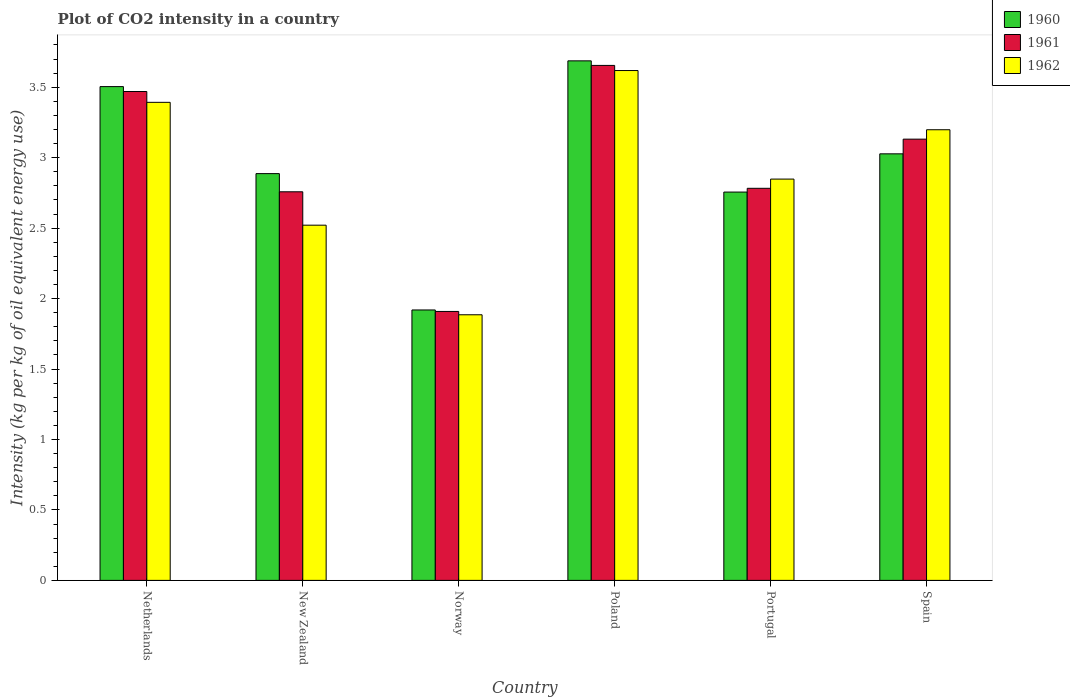How many different coloured bars are there?
Offer a terse response. 3. How many bars are there on the 4th tick from the left?
Give a very brief answer. 3. How many bars are there on the 4th tick from the right?
Your answer should be very brief. 3. In how many cases, is the number of bars for a given country not equal to the number of legend labels?
Your response must be concise. 0. What is the CO2 intensity in in 1961 in Poland?
Ensure brevity in your answer.  3.66. Across all countries, what is the maximum CO2 intensity in in 1961?
Your response must be concise. 3.66. Across all countries, what is the minimum CO2 intensity in in 1962?
Provide a short and direct response. 1.89. In which country was the CO2 intensity in in 1960 maximum?
Keep it short and to the point. Poland. In which country was the CO2 intensity in in 1961 minimum?
Provide a succinct answer. Norway. What is the total CO2 intensity in in 1962 in the graph?
Offer a very short reply. 17.46. What is the difference between the CO2 intensity in in 1962 in Poland and that in Spain?
Your answer should be very brief. 0.42. What is the difference between the CO2 intensity in in 1961 in Spain and the CO2 intensity in in 1962 in Netherlands?
Provide a short and direct response. -0.26. What is the average CO2 intensity in in 1962 per country?
Make the answer very short. 2.91. What is the difference between the CO2 intensity in of/in 1960 and CO2 intensity in of/in 1961 in Poland?
Provide a succinct answer. 0.03. In how many countries, is the CO2 intensity in in 1960 greater than 2.4 kg?
Offer a terse response. 5. What is the ratio of the CO2 intensity in in 1962 in Netherlands to that in Poland?
Give a very brief answer. 0.94. Is the CO2 intensity in in 1962 in Poland less than that in Portugal?
Your answer should be compact. No. Is the difference between the CO2 intensity in in 1960 in Netherlands and Spain greater than the difference between the CO2 intensity in in 1961 in Netherlands and Spain?
Your answer should be very brief. Yes. What is the difference between the highest and the second highest CO2 intensity in in 1960?
Make the answer very short. -0.18. What is the difference between the highest and the lowest CO2 intensity in in 1961?
Your answer should be compact. 1.75. In how many countries, is the CO2 intensity in in 1962 greater than the average CO2 intensity in in 1962 taken over all countries?
Your answer should be very brief. 3. Is the sum of the CO2 intensity in in 1960 in Poland and Spain greater than the maximum CO2 intensity in in 1962 across all countries?
Offer a terse response. Yes. What does the 1st bar from the left in Norway represents?
Keep it short and to the point. 1960. What does the 2nd bar from the right in Spain represents?
Offer a terse response. 1961. Is it the case that in every country, the sum of the CO2 intensity in in 1962 and CO2 intensity in in 1961 is greater than the CO2 intensity in in 1960?
Your answer should be very brief. Yes. How many countries are there in the graph?
Make the answer very short. 6. What is the difference between two consecutive major ticks on the Y-axis?
Your answer should be compact. 0.5. Are the values on the major ticks of Y-axis written in scientific E-notation?
Your response must be concise. No. Does the graph contain any zero values?
Give a very brief answer. No. Does the graph contain grids?
Your response must be concise. No. How many legend labels are there?
Offer a terse response. 3. How are the legend labels stacked?
Provide a succinct answer. Vertical. What is the title of the graph?
Your answer should be very brief. Plot of CO2 intensity in a country. Does "2008" appear as one of the legend labels in the graph?
Your response must be concise. No. What is the label or title of the X-axis?
Provide a short and direct response. Country. What is the label or title of the Y-axis?
Keep it short and to the point. Intensity (kg per kg of oil equivalent energy use). What is the Intensity (kg per kg of oil equivalent energy use) in 1960 in Netherlands?
Make the answer very short. 3.5. What is the Intensity (kg per kg of oil equivalent energy use) of 1961 in Netherlands?
Make the answer very short. 3.47. What is the Intensity (kg per kg of oil equivalent energy use) of 1962 in Netherlands?
Make the answer very short. 3.39. What is the Intensity (kg per kg of oil equivalent energy use) of 1960 in New Zealand?
Provide a succinct answer. 2.89. What is the Intensity (kg per kg of oil equivalent energy use) of 1961 in New Zealand?
Make the answer very short. 2.76. What is the Intensity (kg per kg of oil equivalent energy use) of 1962 in New Zealand?
Offer a very short reply. 2.52. What is the Intensity (kg per kg of oil equivalent energy use) in 1960 in Norway?
Ensure brevity in your answer.  1.92. What is the Intensity (kg per kg of oil equivalent energy use) of 1961 in Norway?
Give a very brief answer. 1.91. What is the Intensity (kg per kg of oil equivalent energy use) of 1962 in Norway?
Offer a terse response. 1.89. What is the Intensity (kg per kg of oil equivalent energy use) of 1960 in Poland?
Offer a very short reply. 3.69. What is the Intensity (kg per kg of oil equivalent energy use) of 1961 in Poland?
Offer a very short reply. 3.66. What is the Intensity (kg per kg of oil equivalent energy use) of 1962 in Poland?
Your response must be concise. 3.62. What is the Intensity (kg per kg of oil equivalent energy use) in 1960 in Portugal?
Ensure brevity in your answer.  2.76. What is the Intensity (kg per kg of oil equivalent energy use) of 1961 in Portugal?
Your response must be concise. 2.78. What is the Intensity (kg per kg of oil equivalent energy use) in 1962 in Portugal?
Ensure brevity in your answer.  2.85. What is the Intensity (kg per kg of oil equivalent energy use) in 1960 in Spain?
Your response must be concise. 3.03. What is the Intensity (kg per kg of oil equivalent energy use) in 1961 in Spain?
Provide a short and direct response. 3.13. What is the Intensity (kg per kg of oil equivalent energy use) in 1962 in Spain?
Your answer should be compact. 3.2. Across all countries, what is the maximum Intensity (kg per kg of oil equivalent energy use) of 1960?
Your answer should be compact. 3.69. Across all countries, what is the maximum Intensity (kg per kg of oil equivalent energy use) in 1961?
Keep it short and to the point. 3.66. Across all countries, what is the maximum Intensity (kg per kg of oil equivalent energy use) in 1962?
Your answer should be compact. 3.62. Across all countries, what is the minimum Intensity (kg per kg of oil equivalent energy use) in 1960?
Your answer should be very brief. 1.92. Across all countries, what is the minimum Intensity (kg per kg of oil equivalent energy use) of 1961?
Provide a succinct answer. 1.91. Across all countries, what is the minimum Intensity (kg per kg of oil equivalent energy use) in 1962?
Ensure brevity in your answer.  1.89. What is the total Intensity (kg per kg of oil equivalent energy use) of 1960 in the graph?
Offer a terse response. 17.78. What is the total Intensity (kg per kg of oil equivalent energy use) of 1961 in the graph?
Give a very brief answer. 17.71. What is the total Intensity (kg per kg of oil equivalent energy use) in 1962 in the graph?
Offer a very short reply. 17.46. What is the difference between the Intensity (kg per kg of oil equivalent energy use) in 1960 in Netherlands and that in New Zealand?
Offer a very short reply. 0.62. What is the difference between the Intensity (kg per kg of oil equivalent energy use) in 1961 in Netherlands and that in New Zealand?
Provide a succinct answer. 0.71. What is the difference between the Intensity (kg per kg of oil equivalent energy use) in 1962 in Netherlands and that in New Zealand?
Provide a succinct answer. 0.87. What is the difference between the Intensity (kg per kg of oil equivalent energy use) of 1960 in Netherlands and that in Norway?
Give a very brief answer. 1.59. What is the difference between the Intensity (kg per kg of oil equivalent energy use) in 1961 in Netherlands and that in Norway?
Provide a succinct answer. 1.56. What is the difference between the Intensity (kg per kg of oil equivalent energy use) in 1962 in Netherlands and that in Norway?
Your answer should be compact. 1.51. What is the difference between the Intensity (kg per kg of oil equivalent energy use) in 1960 in Netherlands and that in Poland?
Keep it short and to the point. -0.18. What is the difference between the Intensity (kg per kg of oil equivalent energy use) of 1961 in Netherlands and that in Poland?
Provide a short and direct response. -0.19. What is the difference between the Intensity (kg per kg of oil equivalent energy use) in 1962 in Netherlands and that in Poland?
Offer a very short reply. -0.23. What is the difference between the Intensity (kg per kg of oil equivalent energy use) of 1960 in Netherlands and that in Portugal?
Your answer should be very brief. 0.75. What is the difference between the Intensity (kg per kg of oil equivalent energy use) in 1961 in Netherlands and that in Portugal?
Give a very brief answer. 0.69. What is the difference between the Intensity (kg per kg of oil equivalent energy use) in 1962 in Netherlands and that in Portugal?
Your response must be concise. 0.54. What is the difference between the Intensity (kg per kg of oil equivalent energy use) in 1960 in Netherlands and that in Spain?
Offer a terse response. 0.48. What is the difference between the Intensity (kg per kg of oil equivalent energy use) in 1961 in Netherlands and that in Spain?
Provide a succinct answer. 0.34. What is the difference between the Intensity (kg per kg of oil equivalent energy use) in 1962 in Netherlands and that in Spain?
Make the answer very short. 0.19. What is the difference between the Intensity (kg per kg of oil equivalent energy use) in 1960 in New Zealand and that in Norway?
Offer a very short reply. 0.97. What is the difference between the Intensity (kg per kg of oil equivalent energy use) of 1961 in New Zealand and that in Norway?
Your answer should be very brief. 0.85. What is the difference between the Intensity (kg per kg of oil equivalent energy use) in 1962 in New Zealand and that in Norway?
Provide a short and direct response. 0.64. What is the difference between the Intensity (kg per kg of oil equivalent energy use) of 1960 in New Zealand and that in Poland?
Make the answer very short. -0.8. What is the difference between the Intensity (kg per kg of oil equivalent energy use) in 1961 in New Zealand and that in Poland?
Keep it short and to the point. -0.9. What is the difference between the Intensity (kg per kg of oil equivalent energy use) in 1962 in New Zealand and that in Poland?
Give a very brief answer. -1.1. What is the difference between the Intensity (kg per kg of oil equivalent energy use) in 1960 in New Zealand and that in Portugal?
Your answer should be very brief. 0.13. What is the difference between the Intensity (kg per kg of oil equivalent energy use) in 1961 in New Zealand and that in Portugal?
Provide a succinct answer. -0.02. What is the difference between the Intensity (kg per kg of oil equivalent energy use) of 1962 in New Zealand and that in Portugal?
Provide a succinct answer. -0.33. What is the difference between the Intensity (kg per kg of oil equivalent energy use) of 1960 in New Zealand and that in Spain?
Give a very brief answer. -0.14. What is the difference between the Intensity (kg per kg of oil equivalent energy use) of 1961 in New Zealand and that in Spain?
Your answer should be very brief. -0.37. What is the difference between the Intensity (kg per kg of oil equivalent energy use) in 1962 in New Zealand and that in Spain?
Make the answer very short. -0.68. What is the difference between the Intensity (kg per kg of oil equivalent energy use) of 1960 in Norway and that in Poland?
Your answer should be compact. -1.77. What is the difference between the Intensity (kg per kg of oil equivalent energy use) in 1961 in Norway and that in Poland?
Provide a short and direct response. -1.75. What is the difference between the Intensity (kg per kg of oil equivalent energy use) of 1962 in Norway and that in Poland?
Offer a very short reply. -1.73. What is the difference between the Intensity (kg per kg of oil equivalent energy use) in 1960 in Norway and that in Portugal?
Your answer should be compact. -0.84. What is the difference between the Intensity (kg per kg of oil equivalent energy use) in 1961 in Norway and that in Portugal?
Give a very brief answer. -0.87. What is the difference between the Intensity (kg per kg of oil equivalent energy use) of 1962 in Norway and that in Portugal?
Make the answer very short. -0.96. What is the difference between the Intensity (kg per kg of oil equivalent energy use) of 1960 in Norway and that in Spain?
Make the answer very short. -1.11. What is the difference between the Intensity (kg per kg of oil equivalent energy use) of 1961 in Norway and that in Spain?
Make the answer very short. -1.22. What is the difference between the Intensity (kg per kg of oil equivalent energy use) in 1962 in Norway and that in Spain?
Ensure brevity in your answer.  -1.31. What is the difference between the Intensity (kg per kg of oil equivalent energy use) in 1960 in Poland and that in Portugal?
Your answer should be compact. 0.93. What is the difference between the Intensity (kg per kg of oil equivalent energy use) in 1961 in Poland and that in Portugal?
Give a very brief answer. 0.87. What is the difference between the Intensity (kg per kg of oil equivalent energy use) in 1962 in Poland and that in Portugal?
Your answer should be compact. 0.77. What is the difference between the Intensity (kg per kg of oil equivalent energy use) in 1960 in Poland and that in Spain?
Your answer should be compact. 0.66. What is the difference between the Intensity (kg per kg of oil equivalent energy use) of 1961 in Poland and that in Spain?
Offer a very short reply. 0.52. What is the difference between the Intensity (kg per kg of oil equivalent energy use) of 1962 in Poland and that in Spain?
Provide a succinct answer. 0.42. What is the difference between the Intensity (kg per kg of oil equivalent energy use) of 1960 in Portugal and that in Spain?
Give a very brief answer. -0.27. What is the difference between the Intensity (kg per kg of oil equivalent energy use) of 1961 in Portugal and that in Spain?
Ensure brevity in your answer.  -0.35. What is the difference between the Intensity (kg per kg of oil equivalent energy use) of 1962 in Portugal and that in Spain?
Make the answer very short. -0.35. What is the difference between the Intensity (kg per kg of oil equivalent energy use) in 1960 in Netherlands and the Intensity (kg per kg of oil equivalent energy use) in 1961 in New Zealand?
Provide a succinct answer. 0.75. What is the difference between the Intensity (kg per kg of oil equivalent energy use) in 1960 in Netherlands and the Intensity (kg per kg of oil equivalent energy use) in 1962 in New Zealand?
Keep it short and to the point. 0.98. What is the difference between the Intensity (kg per kg of oil equivalent energy use) of 1961 in Netherlands and the Intensity (kg per kg of oil equivalent energy use) of 1962 in New Zealand?
Provide a short and direct response. 0.95. What is the difference between the Intensity (kg per kg of oil equivalent energy use) in 1960 in Netherlands and the Intensity (kg per kg of oil equivalent energy use) in 1961 in Norway?
Keep it short and to the point. 1.6. What is the difference between the Intensity (kg per kg of oil equivalent energy use) of 1960 in Netherlands and the Intensity (kg per kg of oil equivalent energy use) of 1962 in Norway?
Provide a short and direct response. 1.62. What is the difference between the Intensity (kg per kg of oil equivalent energy use) in 1961 in Netherlands and the Intensity (kg per kg of oil equivalent energy use) in 1962 in Norway?
Provide a short and direct response. 1.58. What is the difference between the Intensity (kg per kg of oil equivalent energy use) in 1960 in Netherlands and the Intensity (kg per kg of oil equivalent energy use) in 1961 in Poland?
Provide a succinct answer. -0.15. What is the difference between the Intensity (kg per kg of oil equivalent energy use) of 1960 in Netherlands and the Intensity (kg per kg of oil equivalent energy use) of 1962 in Poland?
Offer a terse response. -0.11. What is the difference between the Intensity (kg per kg of oil equivalent energy use) of 1961 in Netherlands and the Intensity (kg per kg of oil equivalent energy use) of 1962 in Poland?
Ensure brevity in your answer.  -0.15. What is the difference between the Intensity (kg per kg of oil equivalent energy use) in 1960 in Netherlands and the Intensity (kg per kg of oil equivalent energy use) in 1961 in Portugal?
Your answer should be very brief. 0.72. What is the difference between the Intensity (kg per kg of oil equivalent energy use) of 1960 in Netherlands and the Intensity (kg per kg of oil equivalent energy use) of 1962 in Portugal?
Give a very brief answer. 0.66. What is the difference between the Intensity (kg per kg of oil equivalent energy use) in 1961 in Netherlands and the Intensity (kg per kg of oil equivalent energy use) in 1962 in Portugal?
Give a very brief answer. 0.62. What is the difference between the Intensity (kg per kg of oil equivalent energy use) of 1960 in Netherlands and the Intensity (kg per kg of oil equivalent energy use) of 1961 in Spain?
Your answer should be compact. 0.37. What is the difference between the Intensity (kg per kg of oil equivalent energy use) in 1960 in Netherlands and the Intensity (kg per kg of oil equivalent energy use) in 1962 in Spain?
Make the answer very short. 0.31. What is the difference between the Intensity (kg per kg of oil equivalent energy use) in 1961 in Netherlands and the Intensity (kg per kg of oil equivalent energy use) in 1962 in Spain?
Keep it short and to the point. 0.27. What is the difference between the Intensity (kg per kg of oil equivalent energy use) of 1960 in New Zealand and the Intensity (kg per kg of oil equivalent energy use) of 1961 in Norway?
Provide a succinct answer. 0.98. What is the difference between the Intensity (kg per kg of oil equivalent energy use) in 1961 in New Zealand and the Intensity (kg per kg of oil equivalent energy use) in 1962 in Norway?
Your response must be concise. 0.87. What is the difference between the Intensity (kg per kg of oil equivalent energy use) in 1960 in New Zealand and the Intensity (kg per kg of oil equivalent energy use) in 1961 in Poland?
Your answer should be compact. -0.77. What is the difference between the Intensity (kg per kg of oil equivalent energy use) of 1960 in New Zealand and the Intensity (kg per kg of oil equivalent energy use) of 1962 in Poland?
Your answer should be very brief. -0.73. What is the difference between the Intensity (kg per kg of oil equivalent energy use) in 1961 in New Zealand and the Intensity (kg per kg of oil equivalent energy use) in 1962 in Poland?
Ensure brevity in your answer.  -0.86. What is the difference between the Intensity (kg per kg of oil equivalent energy use) of 1960 in New Zealand and the Intensity (kg per kg of oil equivalent energy use) of 1961 in Portugal?
Your response must be concise. 0.1. What is the difference between the Intensity (kg per kg of oil equivalent energy use) in 1960 in New Zealand and the Intensity (kg per kg of oil equivalent energy use) in 1962 in Portugal?
Your answer should be compact. 0.04. What is the difference between the Intensity (kg per kg of oil equivalent energy use) in 1961 in New Zealand and the Intensity (kg per kg of oil equivalent energy use) in 1962 in Portugal?
Keep it short and to the point. -0.09. What is the difference between the Intensity (kg per kg of oil equivalent energy use) of 1960 in New Zealand and the Intensity (kg per kg of oil equivalent energy use) of 1961 in Spain?
Give a very brief answer. -0.24. What is the difference between the Intensity (kg per kg of oil equivalent energy use) of 1960 in New Zealand and the Intensity (kg per kg of oil equivalent energy use) of 1962 in Spain?
Keep it short and to the point. -0.31. What is the difference between the Intensity (kg per kg of oil equivalent energy use) in 1961 in New Zealand and the Intensity (kg per kg of oil equivalent energy use) in 1962 in Spain?
Offer a terse response. -0.44. What is the difference between the Intensity (kg per kg of oil equivalent energy use) of 1960 in Norway and the Intensity (kg per kg of oil equivalent energy use) of 1961 in Poland?
Provide a short and direct response. -1.74. What is the difference between the Intensity (kg per kg of oil equivalent energy use) of 1960 in Norway and the Intensity (kg per kg of oil equivalent energy use) of 1962 in Poland?
Your answer should be compact. -1.7. What is the difference between the Intensity (kg per kg of oil equivalent energy use) in 1961 in Norway and the Intensity (kg per kg of oil equivalent energy use) in 1962 in Poland?
Make the answer very short. -1.71. What is the difference between the Intensity (kg per kg of oil equivalent energy use) of 1960 in Norway and the Intensity (kg per kg of oil equivalent energy use) of 1961 in Portugal?
Ensure brevity in your answer.  -0.86. What is the difference between the Intensity (kg per kg of oil equivalent energy use) in 1960 in Norway and the Intensity (kg per kg of oil equivalent energy use) in 1962 in Portugal?
Ensure brevity in your answer.  -0.93. What is the difference between the Intensity (kg per kg of oil equivalent energy use) in 1961 in Norway and the Intensity (kg per kg of oil equivalent energy use) in 1962 in Portugal?
Your response must be concise. -0.94. What is the difference between the Intensity (kg per kg of oil equivalent energy use) of 1960 in Norway and the Intensity (kg per kg of oil equivalent energy use) of 1961 in Spain?
Your answer should be compact. -1.21. What is the difference between the Intensity (kg per kg of oil equivalent energy use) of 1960 in Norway and the Intensity (kg per kg of oil equivalent energy use) of 1962 in Spain?
Offer a terse response. -1.28. What is the difference between the Intensity (kg per kg of oil equivalent energy use) of 1961 in Norway and the Intensity (kg per kg of oil equivalent energy use) of 1962 in Spain?
Make the answer very short. -1.29. What is the difference between the Intensity (kg per kg of oil equivalent energy use) in 1960 in Poland and the Intensity (kg per kg of oil equivalent energy use) in 1961 in Portugal?
Your answer should be very brief. 0.9. What is the difference between the Intensity (kg per kg of oil equivalent energy use) of 1960 in Poland and the Intensity (kg per kg of oil equivalent energy use) of 1962 in Portugal?
Your answer should be compact. 0.84. What is the difference between the Intensity (kg per kg of oil equivalent energy use) of 1961 in Poland and the Intensity (kg per kg of oil equivalent energy use) of 1962 in Portugal?
Make the answer very short. 0.81. What is the difference between the Intensity (kg per kg of oil equivalent energy use) in 1960 in Poland and the Intensity (kg per kg of oil equivalent energy use) in 1961 in Spain?
Offer a terse response. 0.56. What is the difference between the Intensity (kg per kg of oil equivalent energy use) of 1960 in Poland and the Intensity (kg per kg of oil equivalent energy use) of 1962 in Spain?
Offer a terse response. 0.49. What is the difference between the Intensity (kg per kg of oil equivalent energy use) in 1961 in Poland and the Intensity (kg per kg of oil equivalent energy use) in 1962 in Spain?
Offer a terse response. 0.46. What is the difference between the Intensity (kg per kg of oil equivalent energy use) of 1960 in Portugal and the Intensity (kg per kg of oil equivalent energy use) of 1961 in Spain?
Ensure brevity in your answer.  -0.38. What is the difference between the Intensity (kg per kg of oil equivalent energy use) in 1960 in Portugal and the Intensity (kg per kg of oil equivalent energy use) in 1962 in Spain?
Your answer should be very brief. -0.44. What is the difference between the Intensity (kg per kg of oil equivalent energy use) of 1961 in Portugal and the Intensity (kg per kg of oil equivalent energy use) of 1962 in Spain?
Your answer should be compact. -0.42. What is the average Intensity (kg per kg of oil equivalent energy use) in 1960 per country?
Provide a succinct answer. 2.96. What is the average Intensity (kg per kg of oil equivalent energy use) of 1961 per country?
Make the answer very short. 2.95. What is the average Intensity (kg per kg of oil equivalent energy use) in 1962 per country?
Offer a very short reply. 2.91. What is the difference between the Intensity (kg per kg of oil equivalent energy use) of 1960 and Intensity (kg per kg of oil equivalent energy use) of 1961 in Netherlands?
Your answer should be very brief. 0.03. What is the difference between the Intensity (kg per kg of oil equivalent energy use) in 1960 and Intensity (kg per kg of oil equivalent energy use) in 1962 in Netherlands?
Offer a terse response. 0.11. What is the difference between the Intensity (kg per kg of oil equivalent energy use) in 1961 and Intensity (kg per kg of oil equivalent energy use) in 1962 in Netherlands?
Make the answer very short. 0.08. What is the difference between the Intensity (kg per kg of oil equivalent energy use) of 1960 and Intensity (kg per kg of oil equivalent energy use) of 1961 in New Zealand?
Your answer should be very brief. 0.13. What is the difference between the Intensity (kg per kg of oil equivalent energy use) of 1960 and Intensity (kg per kg of oil equivalent energy use) of 1962 in New Zealand?
Offer a terse response. 0.37. What is the difference between the Intensity (kg per kg of oil equivalent energy use) in 1961 and Intensity (kg per kg of oil equivalent energy use) in 1962 in New Zealand?
Make the answer very short. 0.24. What is the difference between the Intensity (kg per kg of oil equivalent energy use) in 1960 and Intensity (kg per kg of oil equivalent energy use) in 1961 in Norway?
Keep it short and to the point. 0.01. What is the difference between the Intensity (kg per kg of oil equivalent energy use) of 1960 and Intensity (kg per kg of oil equivalent energy use) of 1962 in Norway?
Your response must be concise. 0.03. What is the difference between the Intensity (kg per kg of oil equivalent energy use) in 1961 and Intensity (kg per kg of oil equivalent energy use) in 1962 in Norway?
Your answer should be compact. 0.02. What is the difference between the Intensity (kg per kg of oil equivalent energy use) of 1960 and Intensity (kg per kg of oil equivalent energy use) of 1961 in Poland?
Your response must be concise. 0.03. What is the difference between the Intensity (kg per kg of oil equivalent energy use) in 1960 and Intensity (kg per kg of oil equivalent energy use) in 1962 in Poland?
Make the answer very short. 0.07. What is the difference between the Intensity (kg per kg of oil equivalent energy use) of 1961 and Intensity (kg per kg of oil equivalent energy use) of 1962 in Poland?
Offer a terse response. 0.04. What is the difference between the Intensity (kg per kg of oil equivalent energy use) in 1960 and Intensity (kg per kg of oil equivalent energy use) in 1961 in Portugal?
Your answer should be compact. -0.03. What is the difference between the Intensity (kg per kg of oil equivalent energy use) in 1960 and Intensity (kg per kg of oil equivalent energy use) in 1962 in Portugal?
Offer a very short reply. -0.09. What is the difference between the Intensity (kg per kg of oil equivalent energy use) in 1961 and Intensity (kg per kg of oil equivalent energy use) in 1962 in Portugal?
Offer a very short reply. -0.07. What is the difference between the Intensity (kg per kg of oil equivalent energy use) in 1960 and Intensity (kg per kg of oil equivalent energy use) in 1961 in Spain?
Provide a succinct answer. -0.1. What is the difference between the Intensity (kg per kg of oil equivalent energy use) in 1960 and Intensity (kg per kg of oil equivalent energy use) in 1962 in Spain?
Make the answer very short. -0.17. What is the difference between the Intensity (kg per kg of oil equivalent energy use) of 1961 and Intensity (kg per kg of oil equivalent energy use) of 1962 in Spain?
Offer a terse response. -0.07. What is the ratio of the Intensity (kg per kg of oil equivalent energy use) of 1960 in Netherlands to that in New Zealand?
Make the answer very short. 1.21. What is the ratio of the Intensity (kg per kg of oil equivalent energy use) of 1961 in Netherlands to that in New Zealand?
Your answer should be compact. 1.26. What is the ratio of the Intensity (kg per kg of oil equivalent energy use) in 1962 in Netherlands to that in New Zealand?
Offer a terse response. 1.35. What is the ratio of the Intensity (kg per kg of oil equivalent energy use) of 1960 in Netherlands to that in Norway?
Provide a short and direct response. 1.83. What is the ratio of the Intensity (kg per kg of oil equivalent energy use) of 1961 in Netherlands to that in Norway?
Your answer should be compact. 1.82. What is the ratio of the Intensity (kg per kg of oil equivalent energy use) of 1962 in Netherlands to that in Norway?
Your response must be concise. 1.8. What is the ratio of the Intensity (kg per kg of oil equivalent energy use) in 1960 in Netherlands to that in Poland?
Ensure brevity in your answer.  0.95. What is the ratio of the Intensity (kg per kg of oil equivalent energy use) of 1961 in Netherlands to that in Poland?
Your answer should be very brief. 0.95. What is the ratio of the Intensity (kg per kg of oil equivalent energy use) of 1962 in Netherlands to that in Poland?
Ensure brevity in your answer.  0.94. What is the ratio of the Intensity (kg per kg of oil equivalent energy use) in 1960 in Netherlands to that in Portugal?
Make the answer very short. 1.27. What is the ratio of the Intensity (kg per kg of oil equivalent energy use) in 1961 in Netherlands to that in Portugal?
Provide a short and direct response. 1.25. What is the ratio of the Intensity (kg per kg of oil equivalent energy use) of 1962 in Netherlands to that in Portugal?
Give a very brief answer. 1.19. What is the ratio of the Intensity (kg per kg of oil equivalent energy use) in 1960 in Netherlands to that in Spain?
Give a very brief answer. 1.16. What is the ratio of the Intensity (kg per kg of oil equivalent energy use) in 1961 in Netherlands to that in Spain?
Keep it short and to the point. 1.11. What is the ratio of the Intensity (kg per kg of oil equivalent energy use) in 1962 in Netherlands to that in Spain?
Provide a succinct answer. 1.06. What is the ratio of the Intensity (kg per kg of oil equivalent energy use) of 1960 in New Zealand to that in Norway?
Your answer should be compact. 1.5. What is the ratio of the Intensity (kg per kg of oil equivalent energy use) of 1961 in New Zealand to that in Norway?
Offer a very short reply. 1.44. What is the ratio of the Intensity (kg per kg of oil equivalent energy use) of 1962 in New Zealand to that in Norway?
Your answer should be compact. 1.34. What is the ratio of the Intensity (kg per kg of oil equivalent energy use) in 1960 in New Zealand to that in Poland?
Keep it short and to the point. 0.78. What is the ratio of the Intensity (kg per kg of oil equivalent energy use) in 1961 in New Zealand to that in Poland?
Offer a terse response. 0.75. What is the ratio of the Intensity (kg per kg of oil equivalent energy use) of 1962 in New Zealand to that in Poland?
Keep it short and to the point. 0.7. What is the ratio of the Intensity (kg per kg of oil equivalent energy use) in 1960 in New Zealand to that in Portugal?
Offer a very short reply. 1.05. What is the ratio of the Intensity (kg per kg of oil equivalent energy use) of 1962 in New Zealand to that in Portugal?
Your response must be concise. 0.89. What is the ratio of the Intensity (kg per kg of oil equivalent energy use) of 1960 in New Zealand to that in Spain?
Offer a terse response. 0.95. What is the ratio of the Intensity (kg per kg of oil equivalent energy use) of 1961 in New Zealand to that in Spain?
Your response must be concise. 0.88. What is the ratio of the Intensity (kg per kg of oil equivalent energy use) of 1962 in New Zealand to that in Spain?
Provide a short and direct response. 0.79. What is the ratio of the Intensity (kg per kg of oil equivalent energy use) of 1960 in Norway to that in Poland?
Your response must be concise. 0.52. What is the ratio of the Intensity (kg per kg of oil equivalent energy use) in 1961 in Norway to that in Poland?
Your answer should be compact. 0.52. What is the ratio of the Intensity (kg per kg of oil equivalent energy use) of 1962 in Norway to that in Poland?
Your answer should be very brief. 0.52. What is the ratio of the Intensity (kg per kg of oil equivalent energy use) of 1960 in Norway to that in Portugal?
Offer a very short reply. 0.7. What is the ratio of the Intensity (kg per kg of oil equivalent energy use) in 1961 in Norway to that in Portugal?
Keep it short and to the point. 0.69. What is the ratio of the Intensity (kg per kg of oil equivalent energy use) of 1962 in Norway to that in Portugal?
Your answer should be compact. 0.66. What is the ratio of the Intensity (kg per kg of oil equivalent energy use) in 1960 in Norway to that in Spain?
Give a very brief answer. 0.63. What is the ratio of the Intensity (kg per kg of oil equivalent energy use) of 1961 in Norway to that in Spain?
Give a very brief answer. 0.61. What is the ratio of the Intensity (kg per kg of oil equivalent energy use) in 1962 in Norway to that in Spain?
Provide a short and direct response. 0.59. What is the ratio of the Intensity (kg per kg of oil equivalent energy use) of 1960 in Poland to that in Portugal?
Provide a short and direct response. 1.34. What is the ratio of the Intensity (kg per kg of oil equivalent energy use) of 1961 in Poland to that in Portugal?
Make the answer very short. 1.31. What is the ratio of the Intensity (kg per kg of oil equivalent energy use) of 1962 in Poland to that in Portugal?
Your answer should be very brief. 1.27. What is the ratio of the Intensity (kg per kg of oil equivalent energy use) of 1960 in Poland to that in Spain?
Your answer should be compact. 1.22. What is the ratio of the Intensity (kg per kg of oil equivalent energy use) in 1961 in Poland to that in Spain?
Ensure brevity in your answer.  1.17. What is the ratio of the Intensity (kg per kg of oil equivalent energy use) of 1962 in Poland to that in Spain?
Ensure brevity in your answer.  1.13. What is the ratio of the Intensity (kg per kg of oil equivalent energy use) of 1960 in Portugal to that in Spain?
Your response must be concise. 0.91. What is the ratio of the Intensity (kg per kg of oil equivalent energy use) of 1961 in Portugal to that in Spain?
Offer a very short reply. 0.89. What is the ratio of the Intensity (kg per kg of oil equivalent energy use) of 1962 in Portugal to that in Spain?
Keep it short and to the point. 0.89. What is the difference between the highest and the second highest Intensity (kg per kg of oil equivalent energy use) of 1960?
Keep it short and to the point. 0.18. What is the difference between the highest and the second highest Intensity (kg per kg of oil equivalent energy use) in 1961?
Make the answer very short. 0.19. What is the difference between the highest and the second highest Intensity (kg per kg of oil equivalent energy use) of 1962?
Provide a succinct answer. 0.23. What is the difference between the highest and the lowest Intensity (kg per kg of oil equivalent energy use) of 1960?
Give a very brief answer. 1.77. What is the difference between the highest and the lowest Intensity (kg per kg of oil equivalent energy use) in 1961?
Make the answer very short. 1.75. What is the difference between the highest and the lowest Intensity (kg per kg of oil equivalent energy use) of 1962?
Provide a short and direct response. 1.73. 